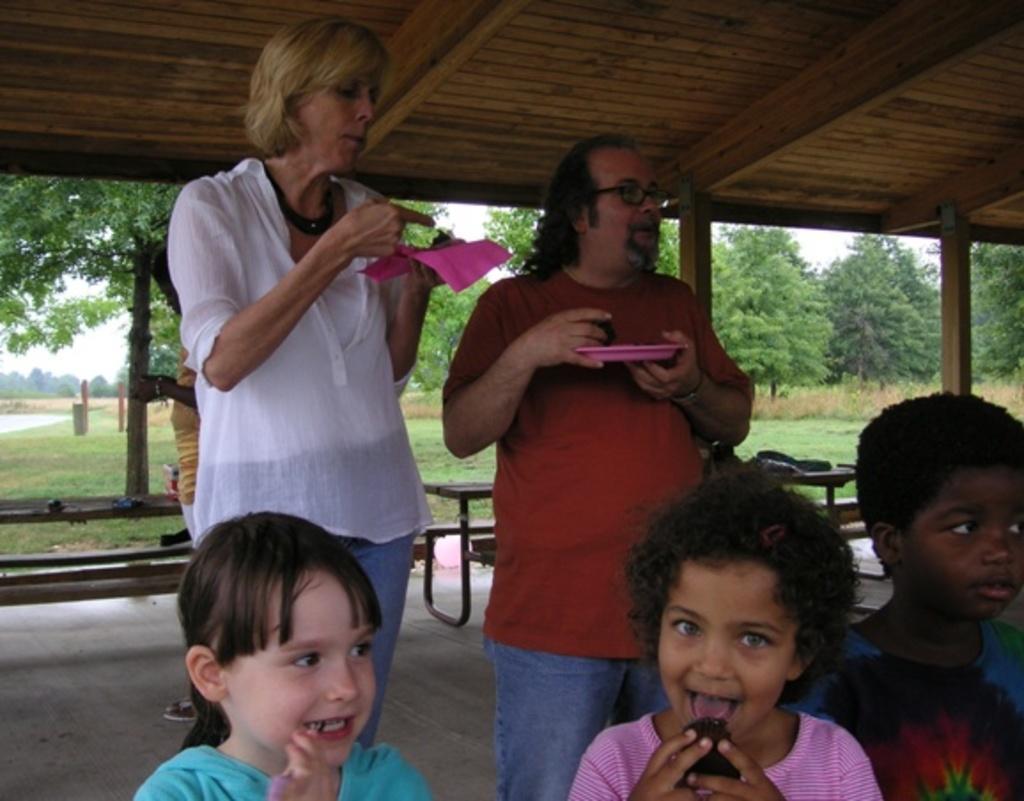In one or two sentences, can you explain what this image depicts? At the bottom of the image there are children. Behind them there are two persons standing and holding a plate. At the top of the image there is wooden ceiling. In the background of the image there are trees, benches, grass. 